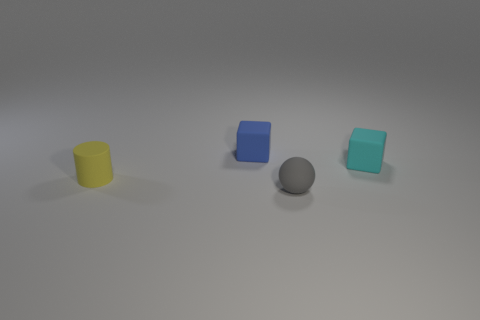Add 3 tiny blue cylinders. How many objects exist? 7 Subtract all blue cubes. How many cubes are left? 1 Subtract all cylinders. How many objects are left? 3 Subtract 1 spheres. How many spheres are left? 0 Subtract all gray cylinders. Subtract all cyan cubes. How many cylinders are left? 1 Subtract all small brown metallic cubes. Subtract all matte cylinders. How many objects are left? 3 Add 3 small blue rubber cubes. How many small blue rubber cubes are left? 4 Add 3 small red blocks. How many small red blocks exist? 3 Subtract 0 cyan spheres. How many objects are left? 4 